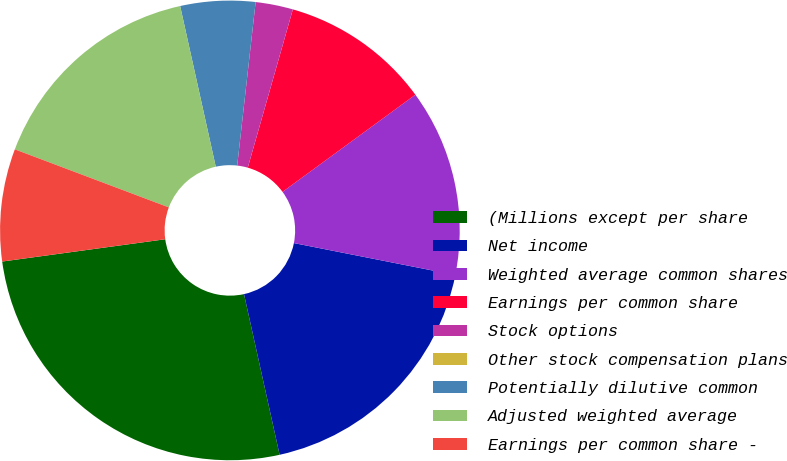<chart> <loc_0><loc_0><loc_500><loc_500><pie_chart><fcel>(Millions except per share<fcel>Net income<fcel>Weighted average common shares<fcel>Earnings per common share<fcel>Stock options<fcel>Other stock compensation plans<fcel>Potentially dilutive common<fcel>Adjusted weighted average<fcel>Earnings per common share -<nl><fcel>26.31%<fcel>18.42%<fcel>13.16%<fcel>10.53%<fcel>2.63%<fcel>0.0%<fcel>5.26%<fcel>15.79%<fcel>7.9%<nl></chart> 